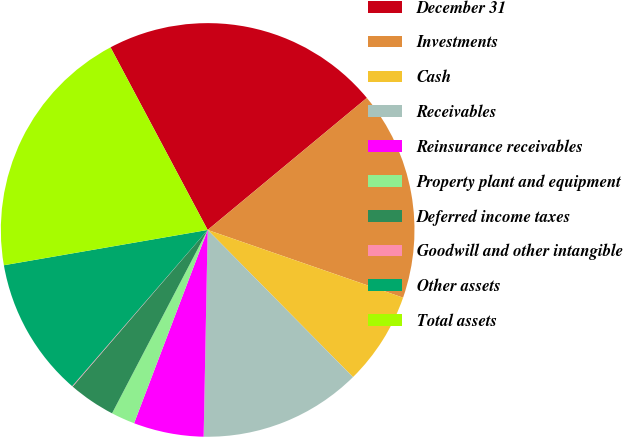Convert chart to OTSL. <chart><loc_0><loc_0><loc_500><loc_500><pie_chart><fcel>December 31<fcel>Investments<fcel>Cash<fcel>Receivables<fcel>Reinsurance receivables<fcel>Property plant and equipment<fcel>Deferred income taxes<fcel>Goodwill and other intangible<fcel>Other assets<fcel>Total assets<nl><fcel>21.76%<fcel>16.33%<fcel>7.29%<fcel>12.71%<fcel>5.48%<fcel>1.86%<fcel>3.67%<fcel>0.05%<fcel>10.9%<fcel>19.95%<nl></chart> 